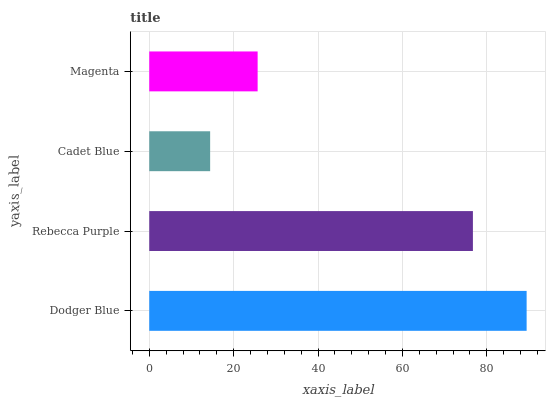Is Cadet Blue the minimum?
Answer yes or no. Yes. Is Dodger Blue the maximum?
Answer yes or no. Yes. Is Rebecca Purple the minimum?
Answer yes or no. No. Is Rebecca Purple the maximum?
Answer yes or no. No. Is Dodger Blue greater than Rebecca Purple?
Answer yes or no. Yes. Is Rebecca Purple less than Dodger Blue?
Answer yes or no. Yes. Is Rebecca Purple greater than Dodger Blue?
Answer yes or no. No. Is Dodger Blue less than Rebecca Purple?
Answer yes or no. No. Is Rebecca Purple the high median?
Answer yes or no. Yes. Is Magenta the low median?
Answer yes or no. Yes. Is Magenta the high median?
Answer yes or no. No. Is Rebecca Purple the low median?
Answer yes or no. No. 